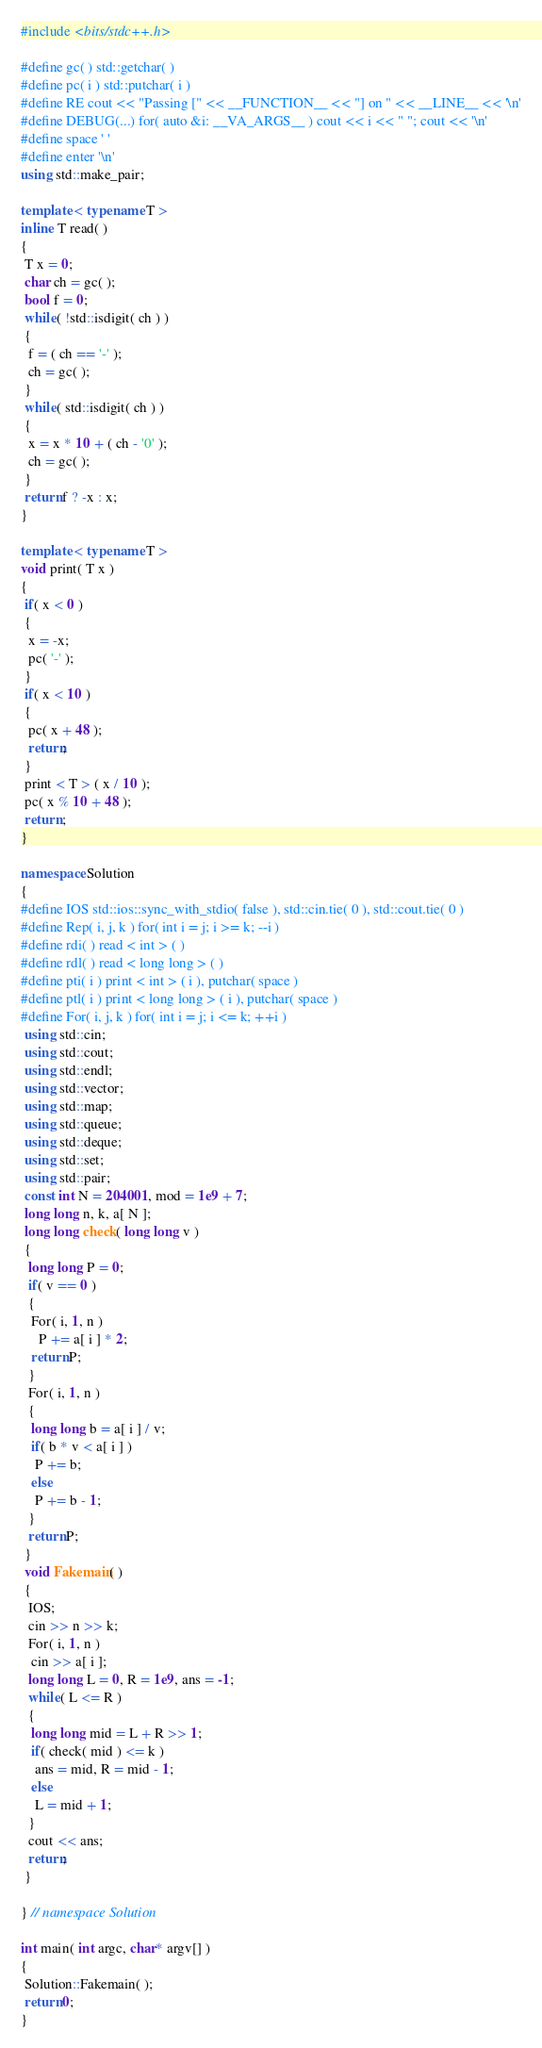<code> <loc_0><loc_0><loc_500><loc_500><_C++_>#include <bits/stdc++.h>

#define gc( ) std::getchar( )
#define pc( i ) std::putchar( i )
#define RE cout << "Passing [" << __FUNCTION__ << "] on " << __LINE__ << '\n'
#define DEBUG(...) for( auto &i: __VA_ARGS__ ) cout << i << " "; cout << '\n'
#define space ' '
#define enter '\n'
using std::make_pair;

template < typename T >
inline T read( )
{
 T x = 0;
 char ch = gc( );
 bool f = 0;
 while( !std::isdigit( ch ) )
 {
  f = ( ch == '-' );
  ch = gc( );
 }
 while( std::isdigit( ch ) )
 {
  x = x * 10 + ( ch - '0' );
  ch = gc( );
 }
 return f ? -x : x;
}

template < typename T >
void print( T x )
{
 if( x < 0 )
 {
  x = -x;
  pc( '-' );
 }
 if( x < 10 )
 {
  pc( x + 48 );
  return;
 }
 print < T > ( x / 10 );
 pc( x % 10 + 48 );
 return ;
}

namespace Solution
{
#define IOS std::ios::sync_with_stdio( false ), std::cin.tie( 0 ), std::cout.tie( 0 )
#define Rep( i, j, k ) for( int i = j; i >= k; --i )
#define rdi( ) read < int > ( )
#define rdl( ) read < long long > ( )
#define pti( i ) print < int > ( i ), putchar( space )
#define ptl( i ) print < long long > ( i ), putchar( space )
#define For( i, j, k ) for( int i = j; i <= k; ++i )
 using std::cin;
 using std::cout;
 using std::endl;
 using std::vector;
 using std::map;
 using std::queue;
 using std::deque;
 using std::set;
 using std::pair;
 const int N = 204001, mod = 1e9 + 7;
 long long n, k, a[ N ];
 long long check( long long v )
 {
  long long P = 0;
  if( v == 0 )
  {
   For( i, 1, n )
     P += a[ i ] * 2;
   return P;
  }
  For( i, 1, n )
  {
   long long b = a[ i ] / v;
   if( b * v < a[ i ] )
    P += b;
   else
    P += b - 1;
  }
  return P;
 }
 void Fakemain( )
 {
  IOS;
  cin >> n >> k;
  For( i, 1, n )
   cin >> a[ i ];
  long long L = 0, R = 1e9, ans = -1;
  while( L <= R )
  {
   long long mid = L + R >> 1;
   if( check( mid ) <= k )
    ans = mid, R = mid - 1;
   else
    L = mid + 1; 
  }
  cout << ans;
  return;
 }

} // namespace Solution

int main( int argc, char* argv[] )
{
 Solution::Fakemain( );
 return 0;
}
</code> 